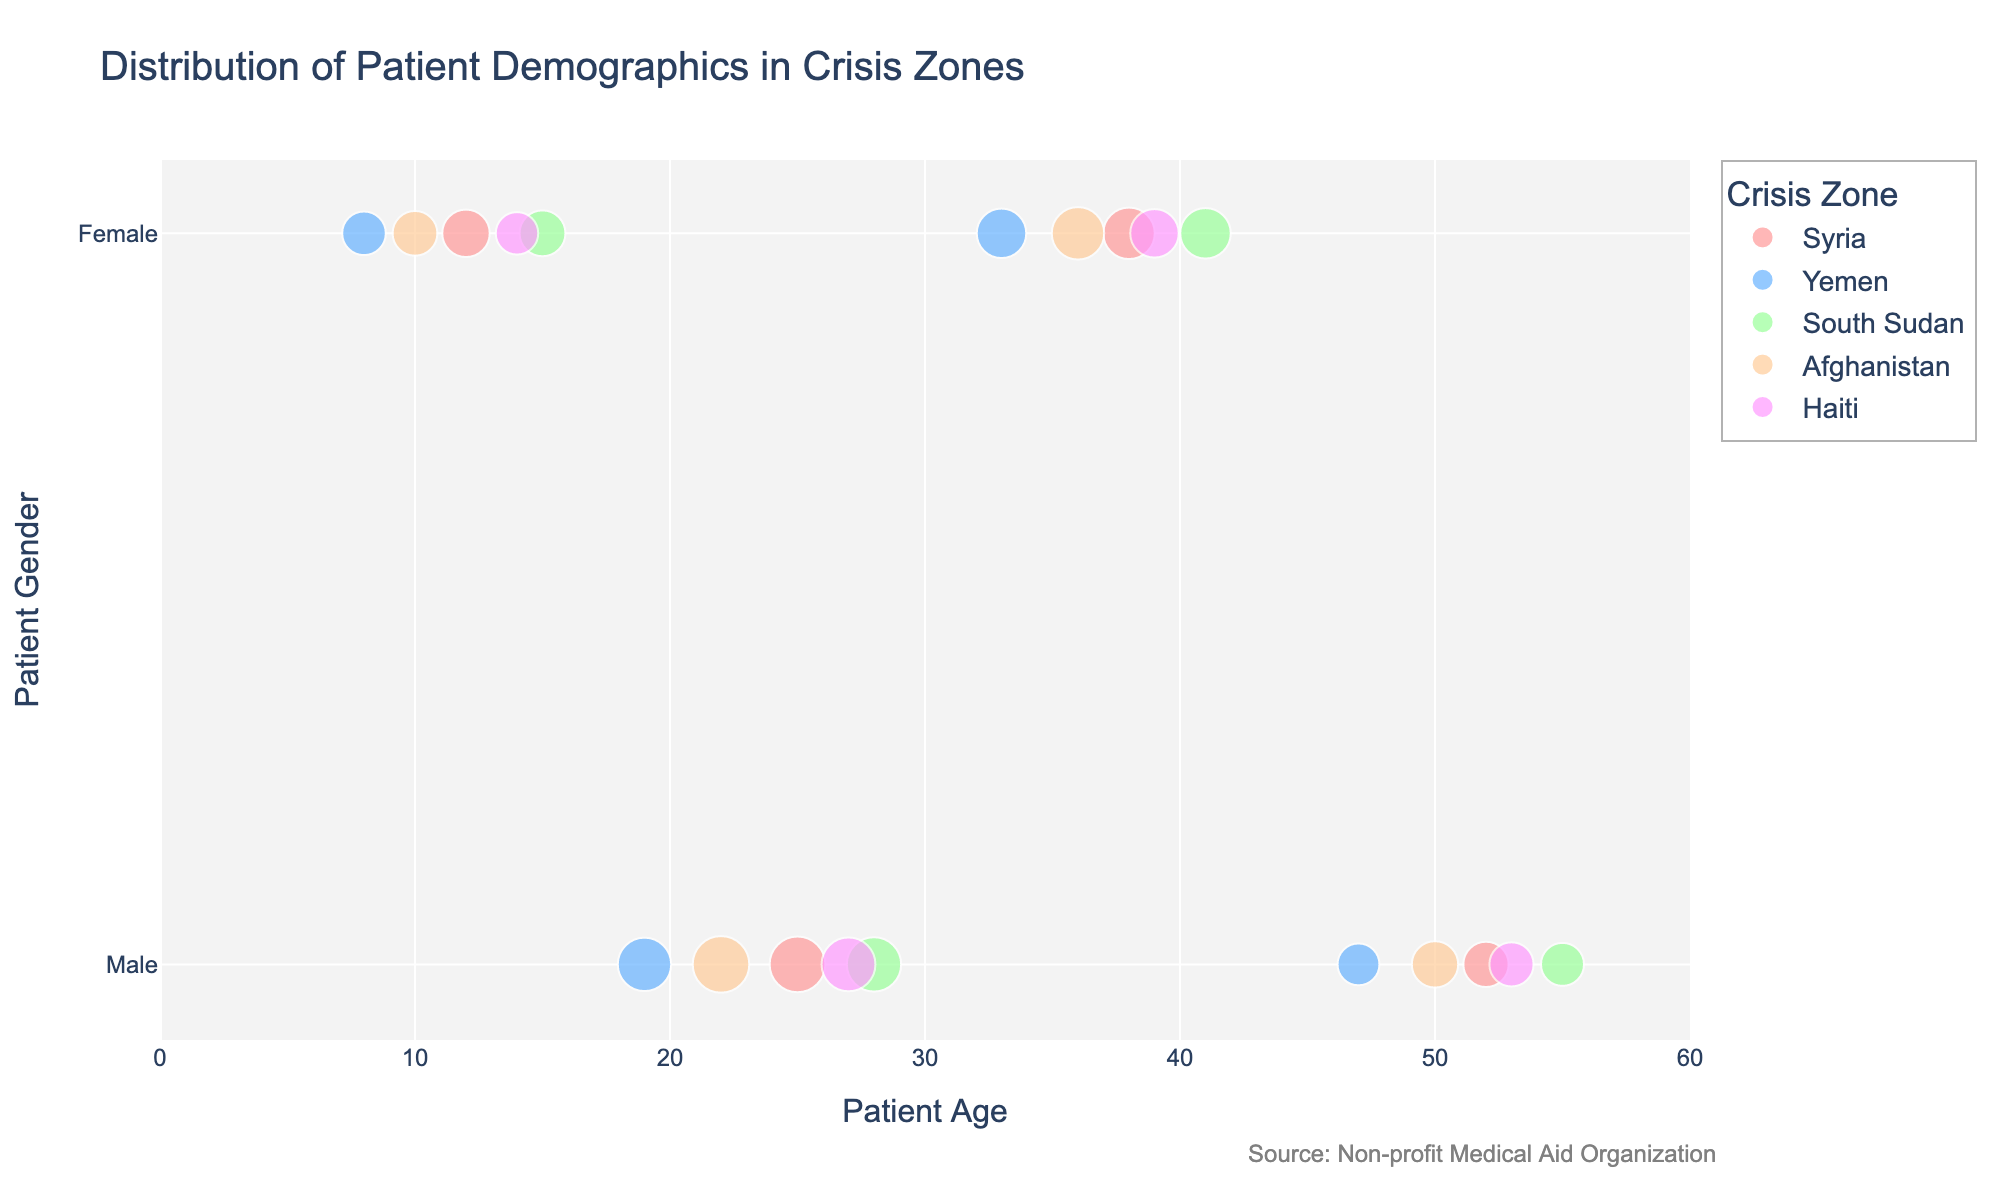What is the title of the figure? The title of the figure is typically positioned at the top and directly describes the main subject of the plot. Here, the title is clearly written at the top, "Distribution of Patient Demographics in Crisis Zones."
Answer: Distribution of Patient Demographics in Crisis Zones Which crisis zone has the highest number of male patients aged 22? By scanning the scatter points, locate the point that corresponds to male patients aged 22. According to the color map, Afghanistan (colored as '#FFCC99') has the highest count of 64 for males aged 22.
Answer: Afghanistan How many patients aged 36 were treated in Afghanistan? Locate the data point for age 36 on the x-axis and check for the corresponding gender and location on the y-axis and color. The point marked with a size of 55 patients is colored '#FFCC99', signifying Afghanistan.
Answer: 55 Which age group has the most patients in Syria? Look at the data points corresponding to Syria (colored '#FF9999'). The scatter point with the largest size in Syria corresponds to males aged 25, which has 62 patients.
Answer: 25 Are there more female patients aged 39 in Haiti or female patients aged 41 in South Sudan? Compare the size of the scatter points for female patients aged 39 in Haiti and female patients aged 41 in South Sudan. Haiti has 47 patients at age 39 (colored '#FF99FF'), and South Sudan has 51 patients at age 41 (colored '#99FF99').
Answer: South Sudan What is the average number of patients treated in Yemen? Add up the counts of all patients in Yemen: 38 (female, 8) + 57 (male, 19) + 49 (female, 33) + 35 (male, 47) and then divide by the number of data points, which is 4. The calculation is (38 + 57 + 49 + 35) / 4.
Answer: 44.75 Which gender has the highest number of patients aged 33 treated in Yemen? Locate the data point for age 33 and match it with the gender and location. Yemen's data point shows 49 patients, and they are female.
Answer: Female What is the sum of male patients across all crisis zones for age groups 22 and 28? Add up the number of male patients aged 22 and 28 across all zones: Afghanistan (64) for age 22 and South Sudan (59) for age 28. The calculation is 64 + 59.
Answer: 123 What is the difference in the number of patients between male patients aged 52 in Syria and male patients aged 53 in Haiti? Find the data points for males aged 52 in Syria and 53 in Haiti. Syria has 41 patients, and Haiti has 39. Compute the difference, 41 - 39.
Answer: 2 Which age group has a comparable number of male and female patients in South Sudan? Identify age groups in South Sudan and compare male and female patient counts. For age 41, 51 female patients, and for age 55, 37 male patients exist. The counts are relatively similar thus we focus on the age group 41 with higher comparability.
Answer: 41 